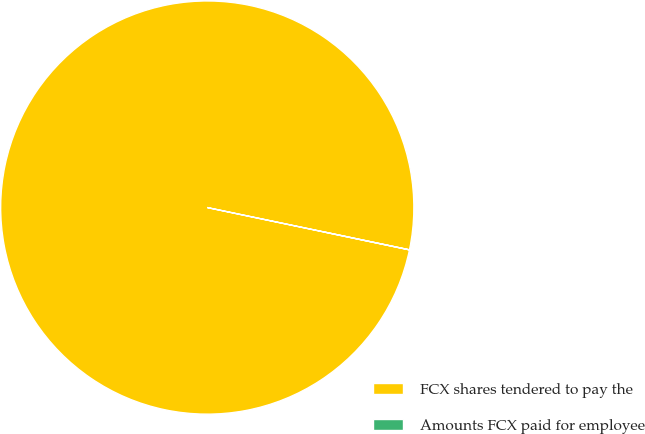<chart> <loc_0><loc_0><loc_500><loc_500><pie_chart><fcel>FCX shares tendered to pay the<fcel>Amounts FCX paid for employee<nl><fcel>100.0%<fcel>0.0%<nl></chart> 